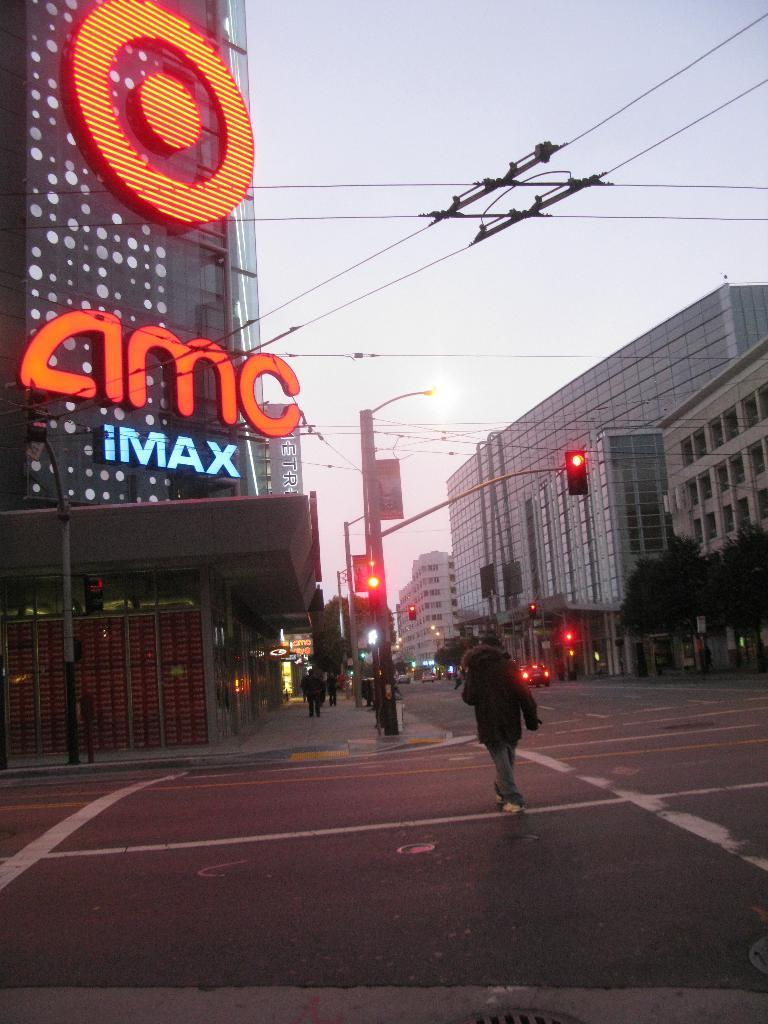<image>
Relay a brief, clear account of the picture shown. An AMC theater has a sign saying it features IMAX. 